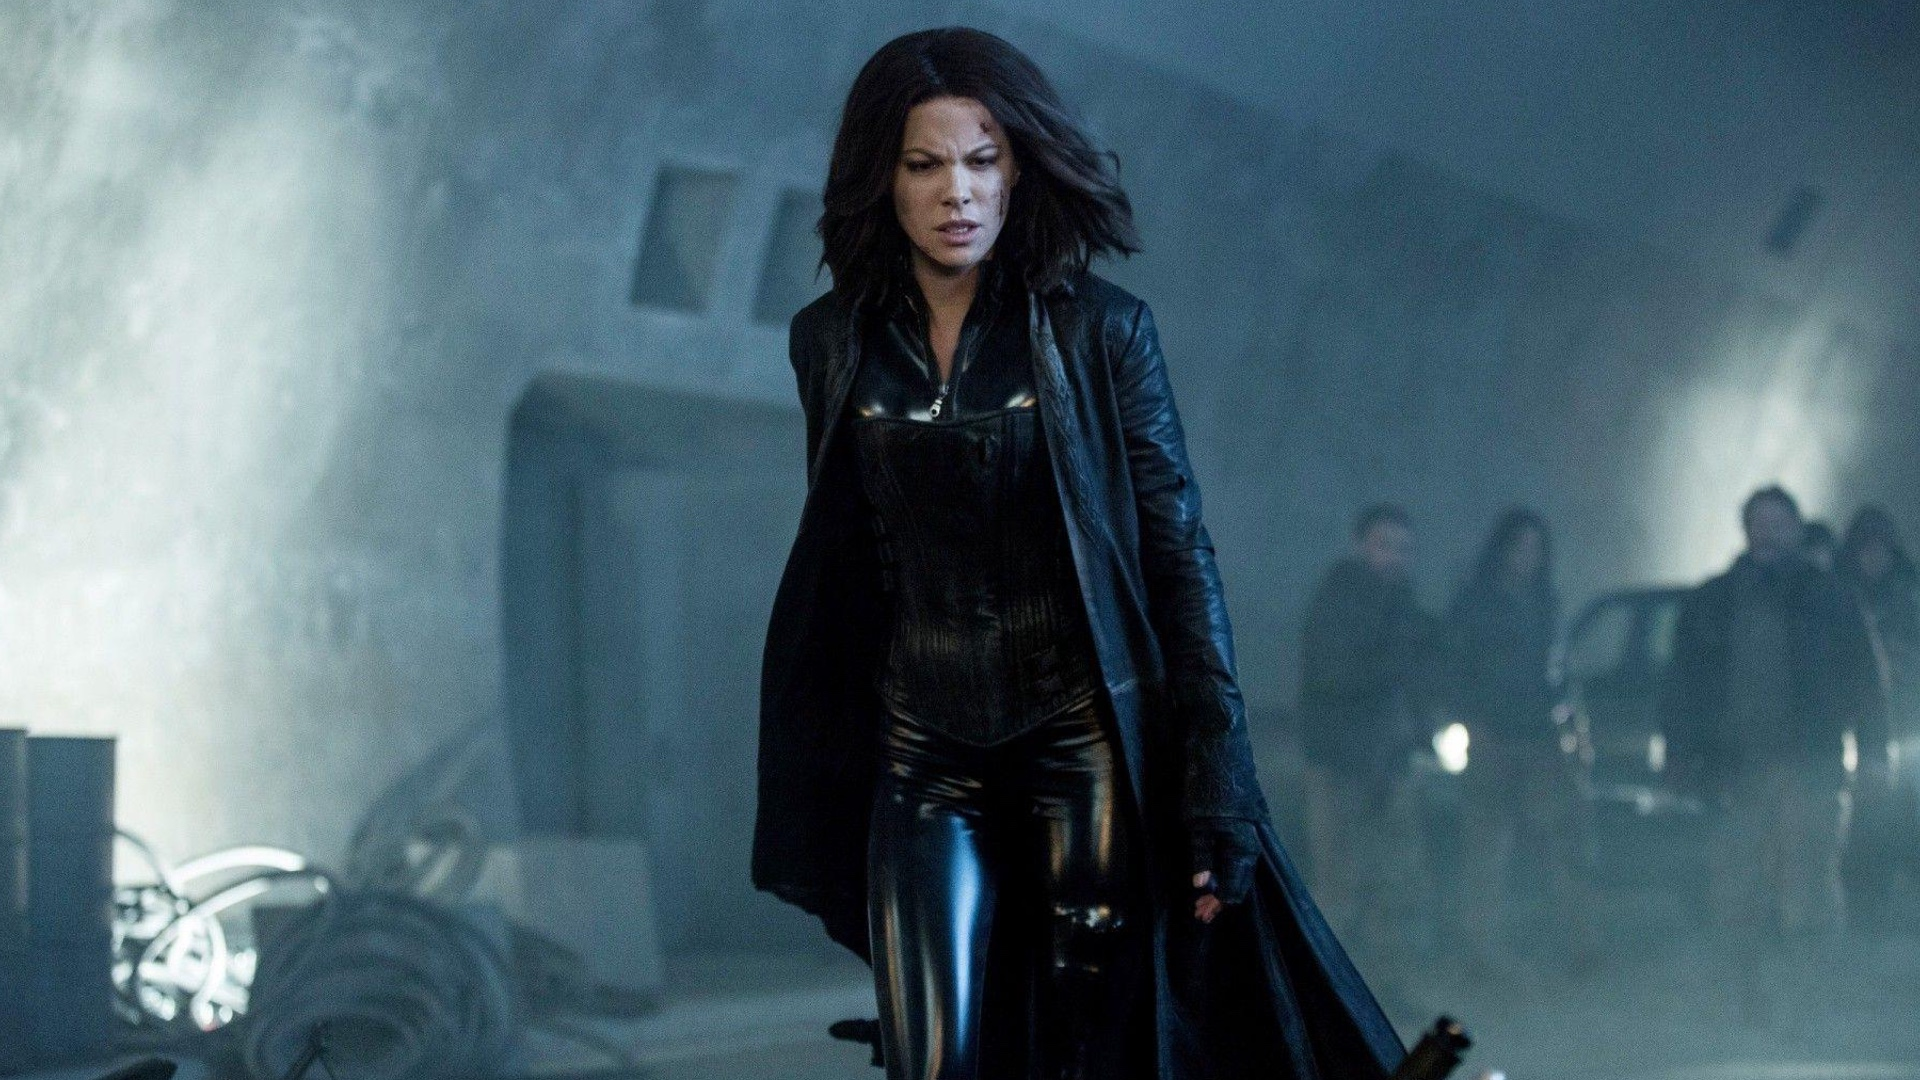How might this scene fit into a larger story? This scene seems to be a pivotal moment where the protagonist is on the move, possibly advancing towards a conflict or resolution. The environment hints at a scene of upcoming action or a significant encounter. The atmospheric tension suggests that this could be part of a larger narrative involving mysterious or supernatural elements, where the central character likely plays a significant role in confronting an impending challenge. 